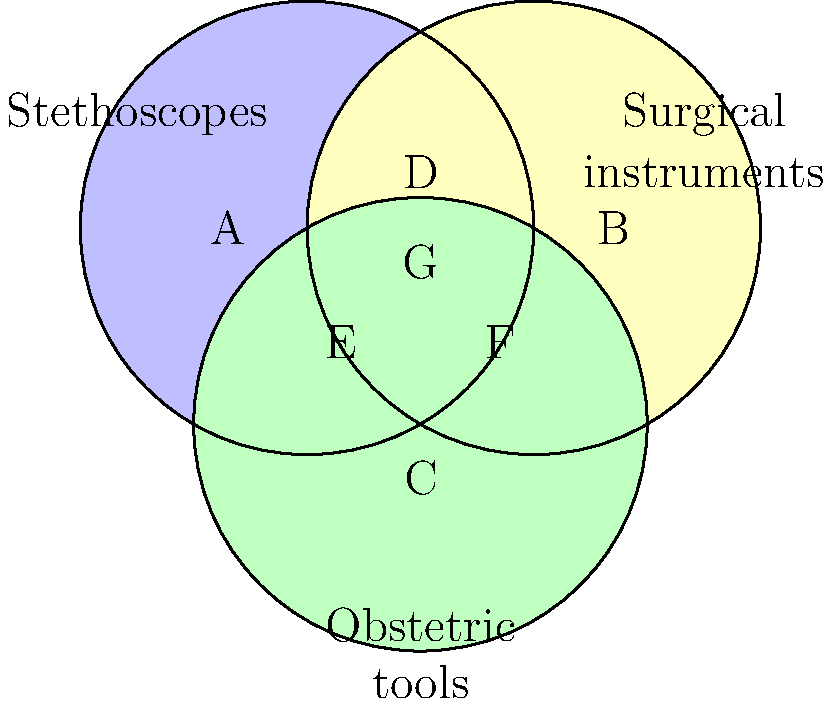In the Venn diagram above, three sets represent different types of medical instruments used by women doctors in New Zealand's medical history: stethoscopes, surgical instruments, and obstetric tools. How many distinct regions are formed by the intersection of these three sets? To determine the number of distinct regions formed by the intersection of three sets in a Venn diagram, we can follow these steps:

1. Identify the regions:
   A: Stethoscopes only
   B: Surgical instruments only
   C: Obstetric tools only
   D: Stethoscopes and surgical instruments
   E: Stethoscopes and obstetric tools
   F: Surgical instruments and obstetric tools
   G: Intersection of all three sets

2. Count the regions:
   There are 7 distinct regions (A, B, C, D, E, F, and G) formed by the intersection of the three sets.

3. Interpret the result:
   Each region represents a unique combination of medical instruments that women doctors in New Zealand's medical history might have used. For example, region G represents instruments that could be classified as stethoscopes, surgical instruments, and obstetric tools simultaneously.

This type of classification is important in understanding the versatility and range of tools used by women in medicine throughout New Zealand's history, reflecting their diverse roles and contributions to various medical specialties.
Answer: 7 